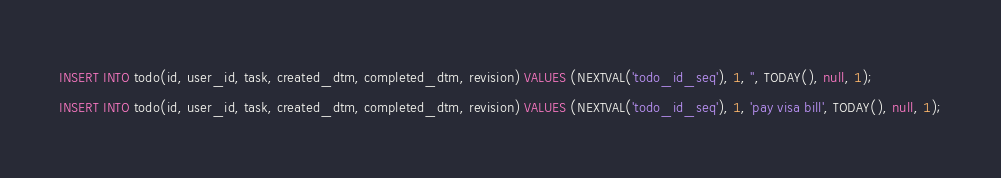<code> <loc_0><loc_0><loc_500><loc_500><_SQL_>
INSERT INTO todo(id, user_id, task, created_dtm, completed_dtm, revision) VALUES (NEXTVAL('todo_id_seq'), 1, '', TODAY(), null, 1);
INSERT INTO todo(id, user_id, task, created_dtm, completed_dtm, revision) VALUES (NEXTVAL('todo_id_seq'), 1, 'pay visa bill', TODAY(), null, 1);</code> 